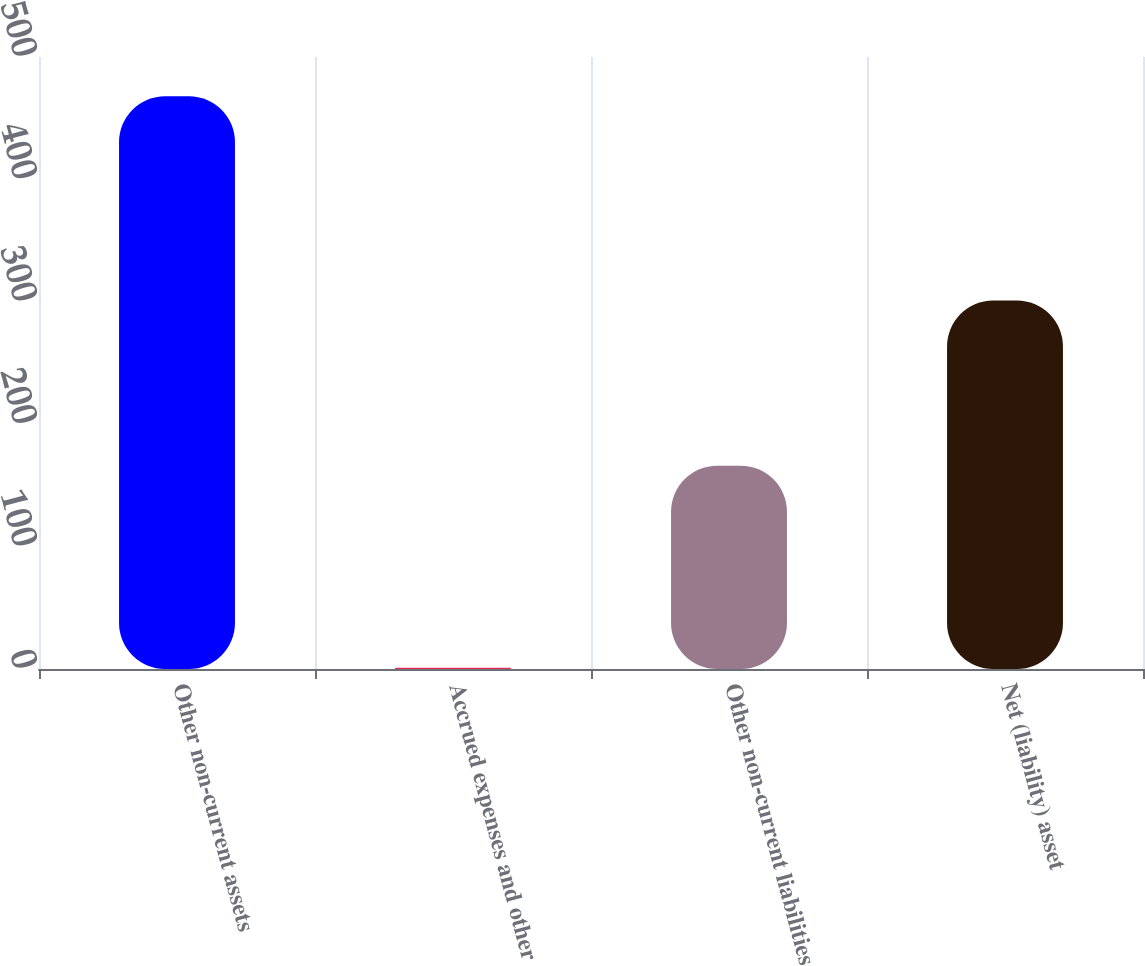<chart> <loc_0><loc_0><loc_500><loc_500><bar_chart><fcel>Other non-current assets<fcel>Accrued expenses and other<fcel>Other non-current liabilities<fcel>Net (liability) asset<nl><fcel>468<fcel>1<fcel>166<fcel>301<nl></chart> 